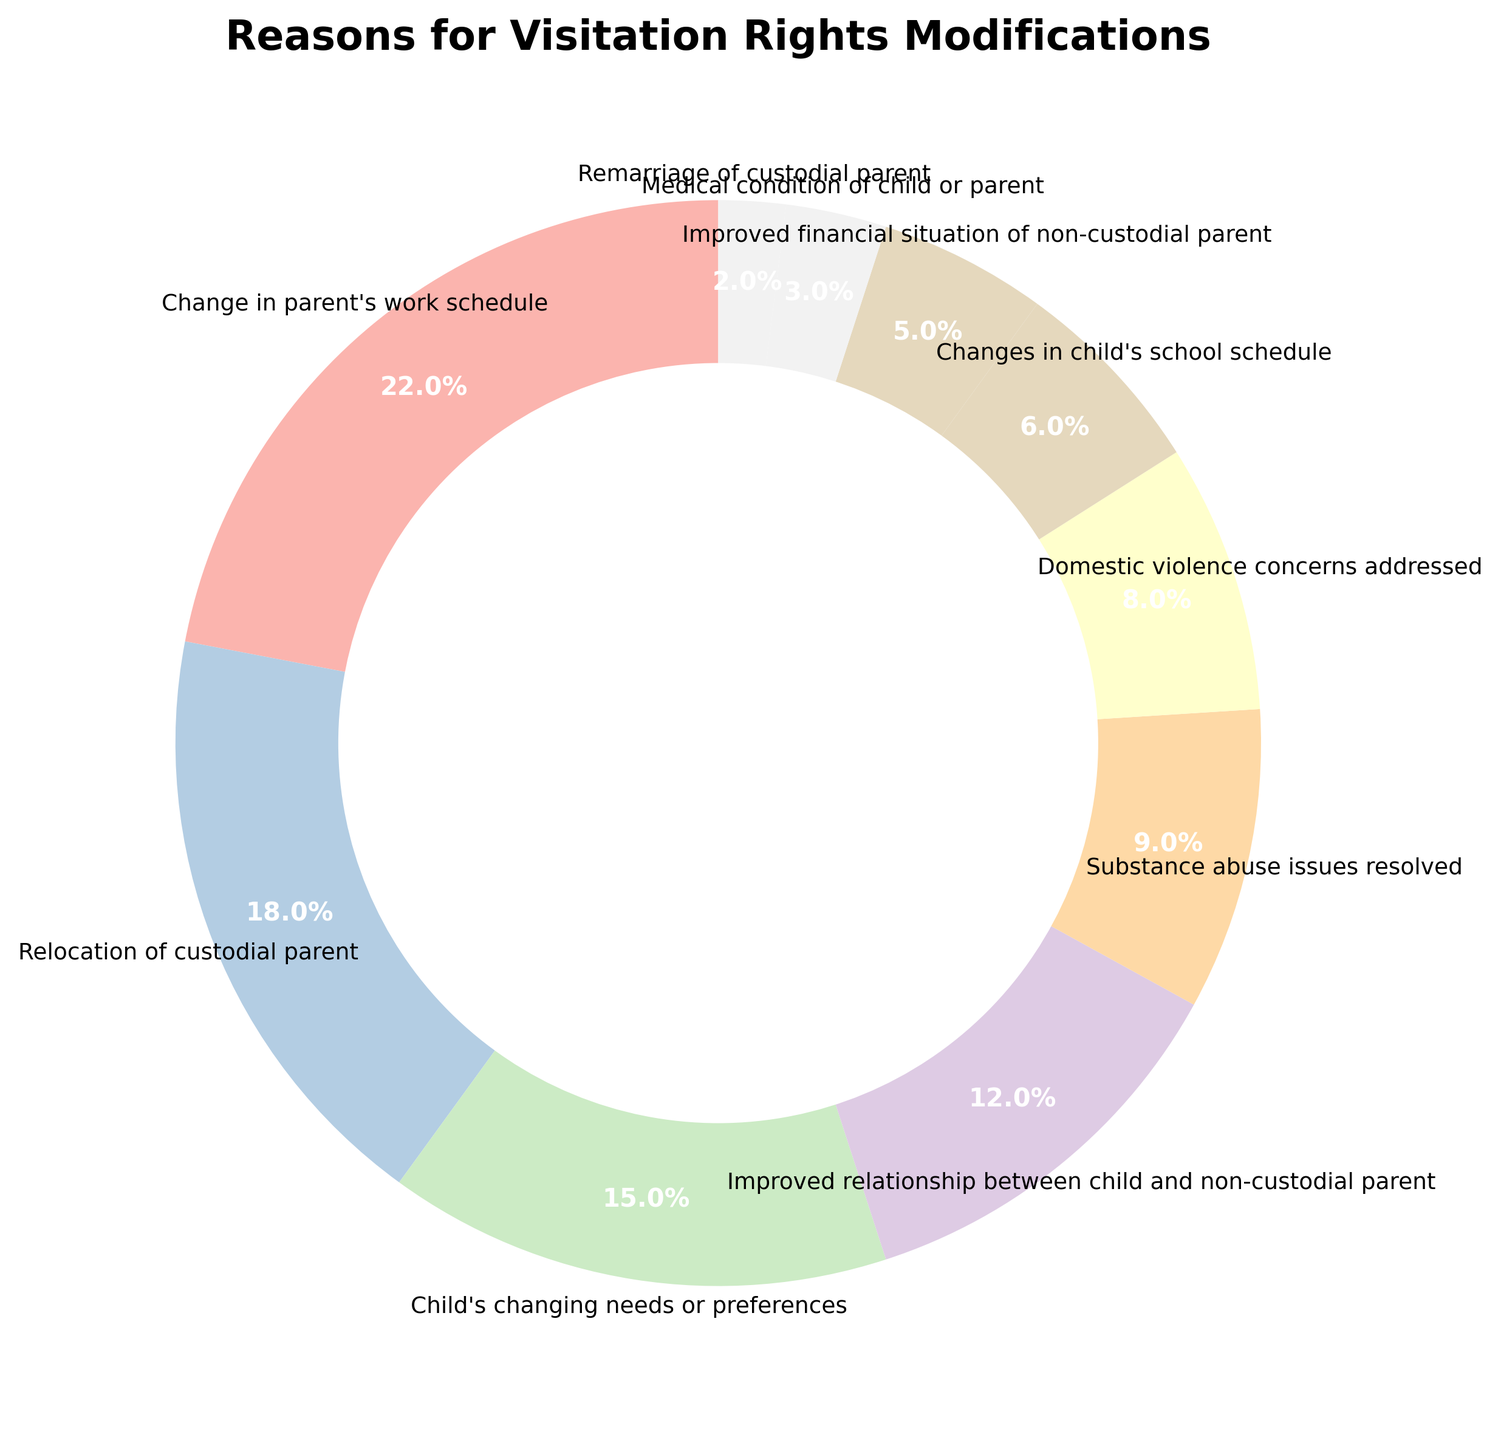Which reason accounts for the largest percentage of visitation rights modifications? The largest slice of the pie chart is the one representing "Change in parent's work schedule," which is visually the largest segment. This indicates it accounts for the largest percentage.
Answer: Change in parent's work schedule Which reason accounts for the smallest percentage? The smallest slice of the pie chart represents "Remarriage of custodial parent," making it the category with the lowest percentage.
Answer: Remarriage of custodial parent What is the combined percentage for "Relocation of custodial parent" and "Child's changing needs or preferences"? The percentage for "Relocation of custodial parent" is 18% and for "Child's changing needs or preferences" is 15%. Adding these together gives 18% + 15% = 33%.
Answer: 33% Which two reasons together make up 30% of the total? The reasons "Domestic violence concerns addressed" (8%) and "Improved relationship between child and non-custodial parent" (12%) together make 8% + 12% = 20%. Adding "Substance abuse issues resolved" (9%) to any of these sets exceeds 30%. Therefore, "Domestic violence concerns addressed" (8%) and "Substance abuse issues resolved" (9%) together make up 17%, so we need to include "Changes in child's school schedule" (6%), and "Improved relationship..." (12%), which makes 18% alone to shift the total. Instead three combined make 35%. There's no two sole set here likely that precisely makes 30%.
Answer: N/A Which is more common: modifications due to "Change in parent's work schedule" or "Improved relationship between child and non-custodial parent"? "Change in parent's work schedule" accounts for 22% while "Improved relationship between child and non-custodial parent" accounts for 12%. Since 22% > 12%, the former is more common.
Answer: Change in parent's work schedule Is the percentage for "Medical condition of child or parent" greater than, equal to, or less than one-fourth of the percentage for "Change in parent's work schedule"? One-fourth of the percentage for "Change in parent's work schedule" (22%) is 22% / 4 = 5.5%. "Medical condition of child or parent" is 3%, which is less than 5.5%.
Answer: Less than How does "Improved financial situation of non-custodial parent" compare to "Changes in child's school schedule" in terms of percentage? "Improved financial situation of non-custodial parent" is 5%, while "Changes in child's school schedule" is 6%. Since 5% < 6%, the former is less common.
Answer: Less 